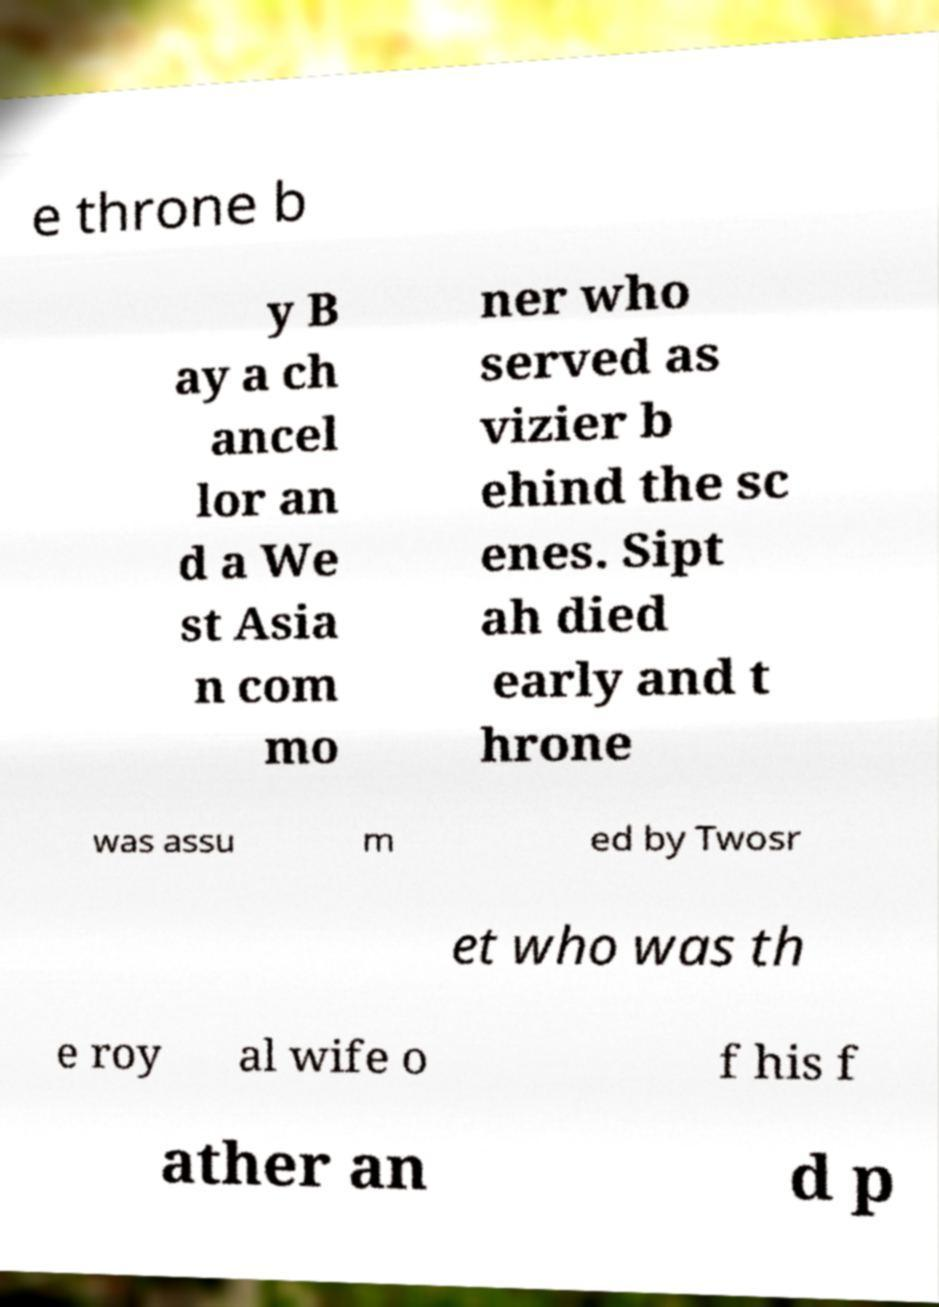Please read and relay the text visible in this image. What does it say? e throne b y B ay a ch ancel lor an d a We st Asia n com mo ner who served as vizier b ehind the sc enes. Sipt ah died early and t hrone was assu m ed by Twosr et who was th e roy al wife o f his f ather an d p 